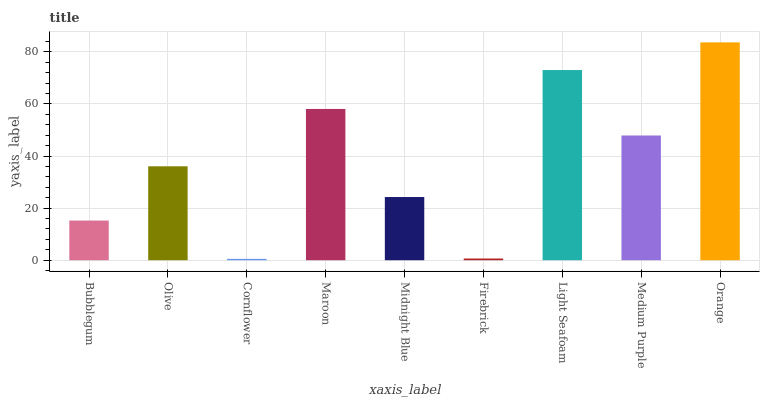Is Cornflower the minimum?
Answer yes or no. Yes. Is Orange the maximum?
Answer yes or no. Yes. Is Olive the minimum?
Answer yes or no. No. Is Olive the maximum?
Answer yes or no. No. Is Olive greater than Bubblegum?
Answer yes or no. Yes. Is Bubblegum less than Olive?
Answer yes or no. Yes. Is Bubblegum greater than Olive?
Answer yes or no. No. Is Olive less than Bubblegum?
Answer yes or no. No. Is Olive the high median?
Answer yes or no. Yes. Is Olive the low median?
Answer yes or no. Yes. Is Firebrick the high median?
Answer yes or no. No. Is Bubblegum the low median?
Answer yes or no. No. 